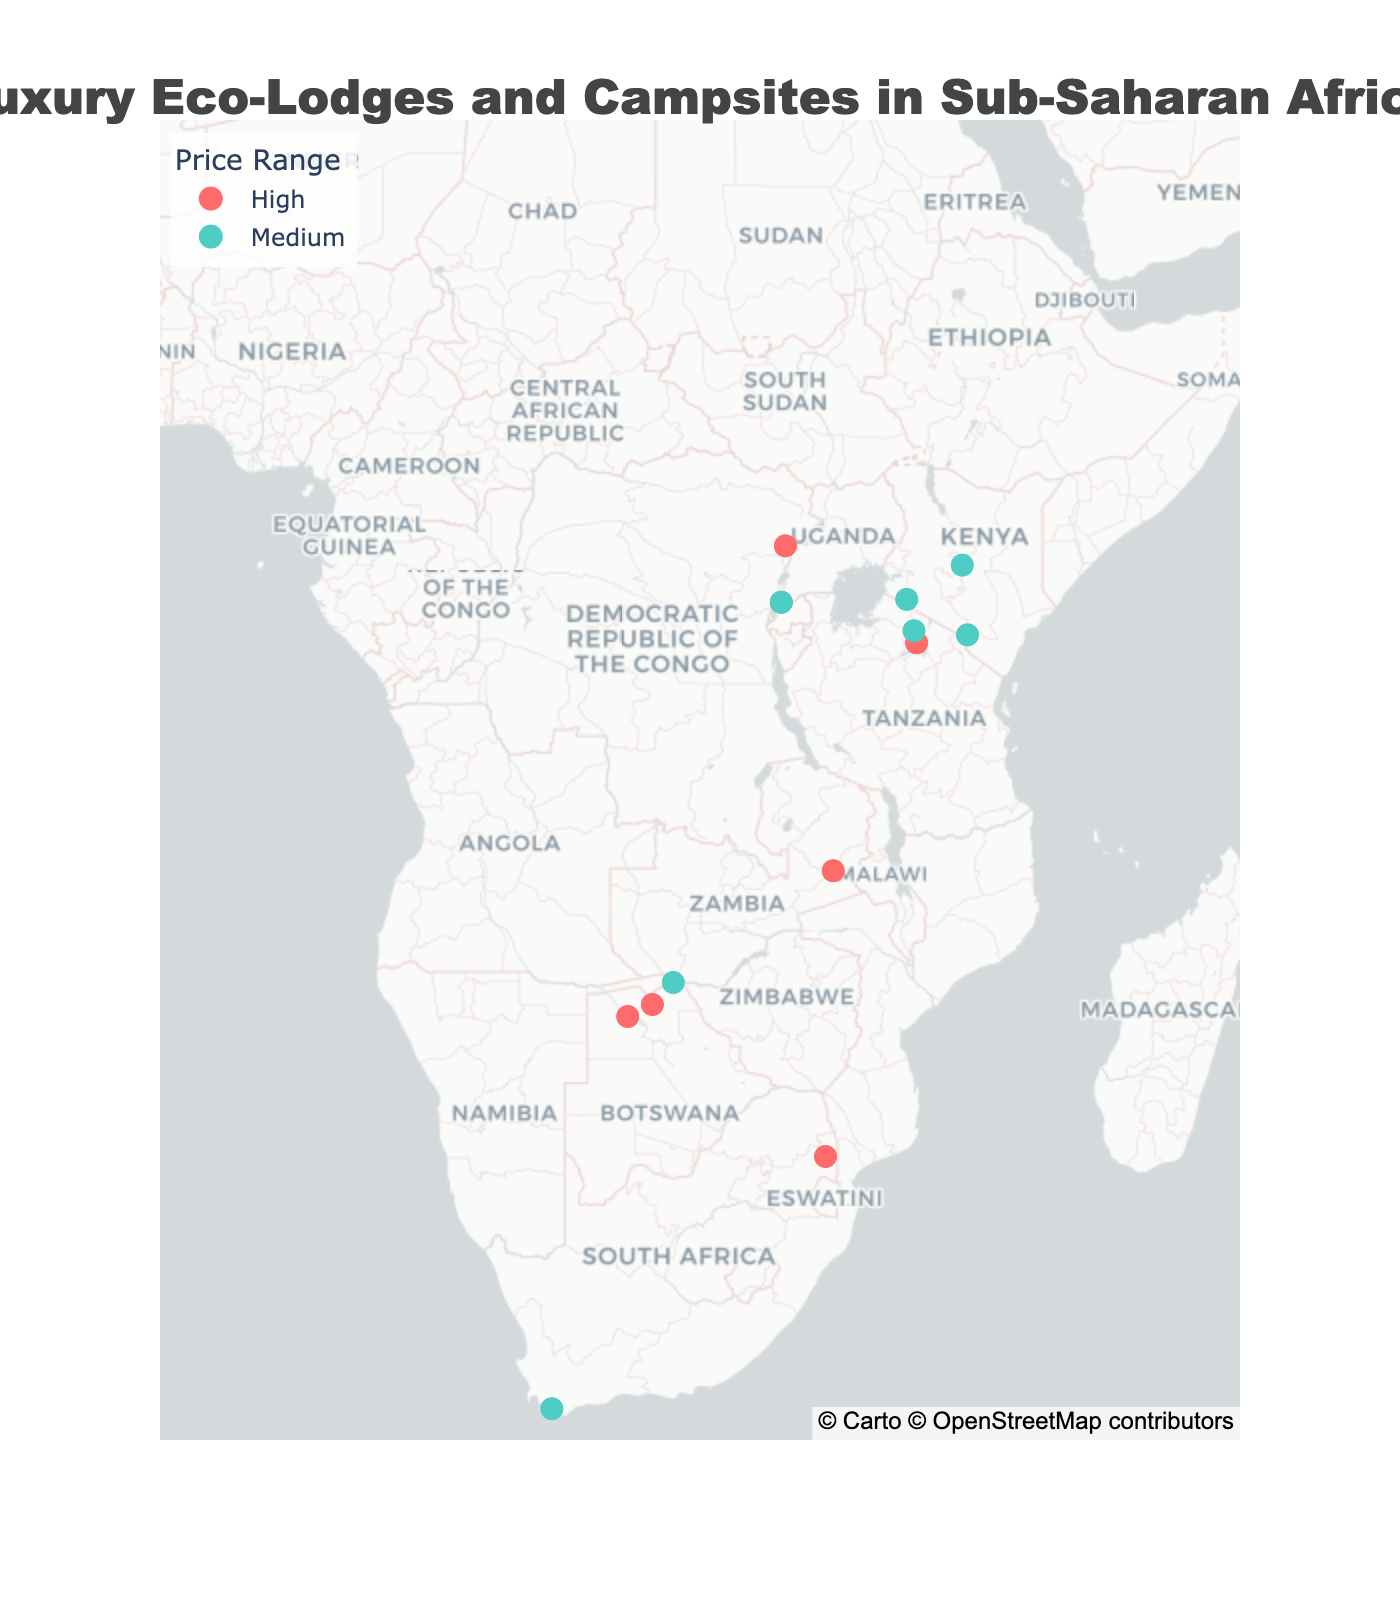How many luxury eco-lodges and campsites are shown in the map figure? Count the total number of data points plotted on the map, which represent the lodges and campsites. Each point corresponds to one lodge or campsite.
Answer: 14 Which type of accommodation (Eco-Lodge or Luxury Campsite) is more frequent on the map? Identify the number of data points for each type by analyzing the hover information or size/color coding if available. Compare the counts to see which type has more occurrences.
Answer: Eco-Lodge Is there a geographical trend visible for high-priced lodges and campsites? Look at the distribution of data points colored to represent the ‘High’ price range. Assess whether they are concentrated in specific regions or scattered.
Answer: Concentrated in Eastern and Southern Africa Which lodge has the northernmost location on the map? Identify the lodge with the highest latitude value, which indicates the northernmost point.
Answer: Sanctuary Gorilla Forest Camp Which lodges or campsites focus on gorillas based on the map data? Use the hover information to filter out lodges and campsites that have ‘Gorillas’ mentioned as their wildlife focus. Examine the map to find these points.
Answer: Sanctuary Gorilla Forest Camp, Bisate Lodge, Virunga Lodge How many lodges or campsites are located in Tanzania? From the latitude and longitude information, identify the points within the geographical boundaries of Tanzania and count them.
Answer: 3 What is the most common wildlife focus among luxury campsites on the map? Filter luxury campsites using the hover information. Then identify the most frequently occurring wildlife focus among these campsites.
Answer: Big Cats Which lodge or campsite with a Big Five wildlife focus is the furthest south? Filter for lodges and campsites with a ‘Big Five’ focus using the hover details, then identify the one with the lowest latitude value, indicating the southernmost location.
Answer: Sabi Sabi Earth Lodge Are lodges and campsites with medium price range evenly distributed? Visually inspect the distribution of data points with the color that represents medium price range across the map. Determine if they appear balanced across different regions or concentrated in specific areas.
Answer: Relatively evenly distributed What proportion of lodges and campsites focuses on the Big Five? Count the total number of lodges and campsites focusing on the Big Five and divide by the total number of lodges and campsites on the map. Multiply by 100 to get the percentage.
Answer: 42.9% 